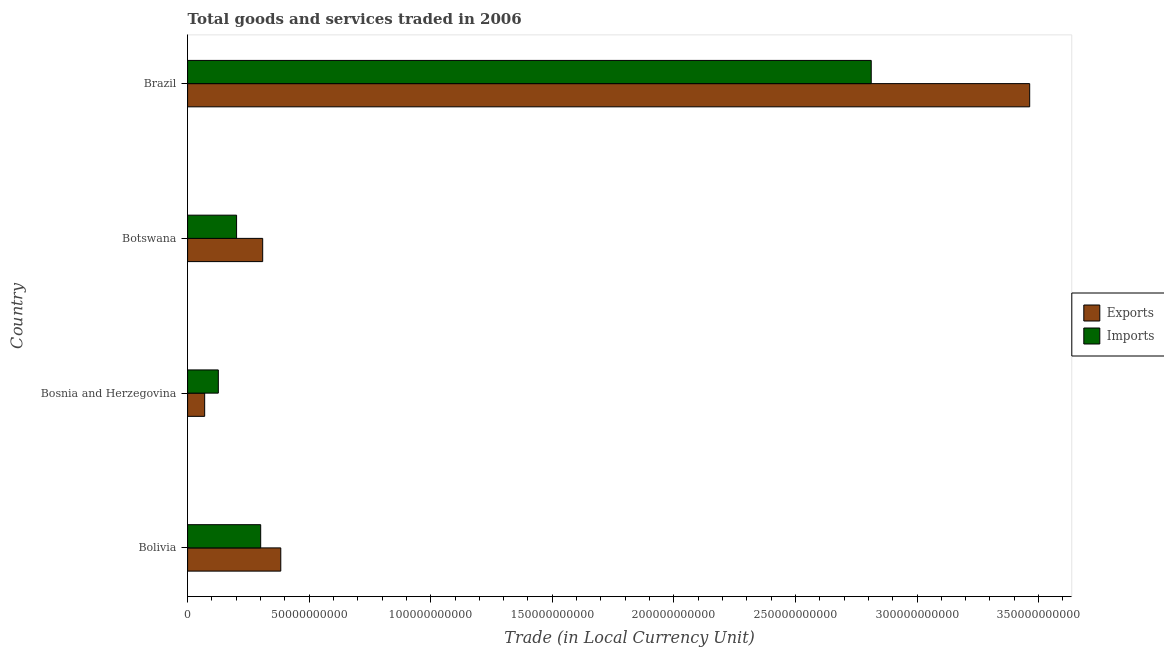How many different coloured bars are there?
Your answer should be very brief. 2. Are the number of bars per tick equal to the number of legend labels?
Your answer should be compact. Yes. How many bars are there on the 2nd tick from the top?
Ensure brevity in your answer.  2. What is the export of goods and services in Brazil?
Make the answer very short. 3.46e+11. Across all countries, what is the maximum imports of goods and services?
Make the answer very short. 2.81e+11. Across all countries, what is the minimum imports of goods and services?
Make the answer very short. 1.26e+1. In which country was the imports of goods and services minimum?
Provide a short and direct response. Bosnia and Herzegovina. What is the total export of goods and services in the graph?
Provide a short and direct response. 4.23e+11. What is the difference between the export of goods and services in Bolivia and that in Brazil?
Your answer should be very brief. -3.08e+11. What is the difference between the imports of goods and services in Brazil and the export of goods and services in Bolivia?
Keep it short and to the point. 2.43e+11. What is the average export of goods and services per country?
Provide a succinct answer. 1.06e+11. What is the difference between the export of goods and services and imports of goods and services in Brazil?
Your response must be concise. 6.52e+1. In how many countries, is the imports of goods and services greater than 60000000000 LCU?
Provide a short and direct response. 1. What is the ratio of the export of goods and services in Bosnia and Herzegovina to that in Botswana?
Offer a very short reply. 0.23. Is the export of goods and services in Bolivia less than that in Bosnia and Herzegovina?
Keep it short and to the point. No. What is the difference between the highest and the second highest export of goods and services?
Your answer should be very brief. 3.08e+11. What is the difference between the highest and the lowest imports of goods and services?
Keep it short and to the point. 2.69e+11. In how many countries, is the export of goods and services greater than the average export of goods and services taken over all countries?
Your answer should be compact. 1. What does the 1st bar from the top in Bosnia and Herzegovina represents?
Ensure brevity in your answer.  Imports. What does the 1st bar from the bottom in Bolivia represents?
Keep it short and to the point. Exports. How many bars are there?
Offer a very short reply. 8. Are all the bars in the graph horizontal?
Offer a very short reply. Yes. Are the values on the major ticks of X-axis written in scientific E-notation?
Give a very brief answer. No. Does the graph contain any zero values?
Offer a very short reply. No. Does the graph contain grids?
Offer a very short reply. No. Where does the legend appear in the graph?
Your response must be concise. Center right. How many legend labels are there?
Offer a very short reply. 2. How are the legend labels stacked?
Ensure brevity in your answer.  Vertical. What is the title of the graph?
Provide a succinct answer. Total goods and services traded in 2006. What is the label or title of the X-axis?
Your response must be concise. Trade (in Local Currency Unit). What is the label or title of the Y-axis?
Offer a very short reply. Country. What is the Trade (in Local Currency Unit) of Exports in Bolivia?
Provide a short and direct response. 3.83e+1. What is the Trade (in Local Currency Unit) in Imports in Bolivia?
Provide a succinct answer. 3.01e+1. What is the Trade (in Local Currency Unit) of Exports in Bosnia and Herzegovina?
Your answer should be compact. 7.02e+09. What is the Trade (in Local Currency Unit) of Imports in Bosnia and Herzegovina?
Ensure brevity in your answer.  1.26e+1. What is the Trade (in Local Currency Unit) of Exports in Botswana?
Offer a very short reply. 3.09e+1. What is the Trade (in Local Currency Unit) in Imports in Botswana?
Keep it short and to the point. 2.01e+1. What is the Trade (in Local Currency Unit) in Exports in Brazil?
Your answer should be compact. 3.46e+11. What is the Trade (in Local Currency Unit) in Imports in Brazil?
Offer a terse response. 2.81e+11. Across all countries, what is the maximum Trade (in Local Currency Unit) in Exports?
Offer a terse response. 3.46e+11. Across all countries, what is the maximum Trade (in Local Currency Unit) of Imports?
Make the answer very short. 2.81e+11. Across all countries, what is the minimum Trade (in Local Currency Unit) in Exports?
Offer a very short reply. 7.02e+09. Across all countries, what is the minimum Trade (in Local Currency Unit) in Imports?
Ensure brevity in your answer.  1.26e+1. What is the total Trade (in Local Currency Unit) in Exports in the graph?
Ensure brevity in your answer.  4.23e+11. What is the total Trade (in Local Currency Unit) of Imports in the graph?
Ensure brevity in your answer.  3.44e+11. What is the difference between the Trade (in Local Currency Unit) in Exports in Bolivia and that in Bosnia and Herzegovina?
Keep it short and to the point. 3.13e+1. What is the difference between the Trade (in Local Currency Unit) of Imports in Bolivia and that in Bosnia and Herzegovina?
Ensure brevity in your answer.  1.74e+1. What is the difference between the Trade (in Local Currency Unit) of Exports in Bolivia and that in Botswana?
Ensure brevity in your answer.  7.44e+09. What is the difference between the Trade (in Local Currency Unit) in Imports in Bolivia and that in Botswana?
Offer a terse response. 9.92e+09. What is the difference between the Trade (in Local Currency Unit) of Exports in Bolivia and that in Brazil?
Your answer should be very brief. -3.08e+11. What is the difference between the Trade (in Local Currency Unit) of Imports in Bolivia and that in Brazil?
Provide a succinct answer. -2.51e+11. What is the difference between the Trade (in Local Currency Unit) in Exports in Bosnia and Herzegovina and that in Botswana?
Keep it short and to the point. -2.39e+1. What is the difference between the Trade (in Local Currency Unit) in Imports in Bosnia and Herzegovina and that in Botswana?
Offer a terse response. -7.50e+09. What is the difference between the Trade (in Local Currency Unit) in Exports in Bosnia and Herzegovina and that in Brazil?
Your answer should be very brief. -3.39e+11. What is the difference between the Trade (in Local Currency Unit) in Imports in Bosnia and Herzegovina and that in Brazil?
Offer a terse response. -2.69e+11. What is the difference between the Trade (in Local Currency Unit) of Exports in Botswana and that in Brazil?
Keep it short and to the point. -3.15e+11. What is the difference between the Trade (in Local Currency Unit) in Imports in Botswana and that in Brazil?
Your answer should be very brief. -2.61e+11. What is the difference between the Trade (in Local Currency Unit) of Exports in Bolivia and the Trade (in Local Currency Unit) of Imports in Bosnia and Herzegovina?
Your answer should be very brief. 2.57e+1. What is the difference between the Trade (in Local Currency Unit) in Exports in Bolivia and the Trade (in Local Currency Unit) in Imports in Botswana?
Offer a very short reply. 1.82e+1. What is the difference between the Trade (in Local Currency Unit) of Exports in Bolivia and the Trade (in Local Currency Unit) of Imports in Brazil?
Ensure brevity in your answer.  -2.43e+11. What is the difference between the Trade (in Local Currency Unit) of Exports in Bosnia and Herzegovina and the Trade (in Local Currency Unit) of Imports in Botswana?
Your answer should be compact. -1.31e+1. What is the difference between the Trade (in Local Currency Unit) of Exports in Bosnia and Herzegovina and the Trade (in Local Currency Unit) of Imports in Brazil?
Your response must be concise. -2.74e+11. What is the difference between the Trade (in Local Currency Unit) in Exports in Botswana and the Trade (in Local Currency Unit) in Imports in Brazil?
Offer a terse response. -2.50e+11. What is the average Trade (in Local Currency Unit) of Exports per country?
Make the answer very short. 1.06e+11. What is the average Trade (in Local Currency Unit) in Imports per country?
Your answer should be very brief. 8.60e+1. What is the difference between the Trade (in Local Currency Unit) of Exports and Trade (in Local Currency Unit) of Imports in Bolivia?
Give a very brief answer. 8.26e+09. What is the difference between the Trade (in Local Currency Unit) of Exports and Trade (in Local Currency Unit) of Imports in Bosnia and Herzegovina?
Your answer should be compact. -5.62e+09. What is the difference between the Trade (in Local Currency Unit) of Exports and Trade (in Local Currency Unit) of Imports in Botswana?
Provide a succinct answer. 1.07e+1. What is the difference between the Trade (in Local Currency Unit) of Exports and Trade (in Local Currency Unit) of Imports in Brazil?
Keep it short and to the point. 6.52e+1. What is the ratio of the Trade (in Local Currency Unit) in Exports in Bolivia to that in Bosnia and Herzegovina?
Offer a very short reply. 5.46. What is the ratio of the Trade (in Local Currency Unit) in Imports in Bolivia to that in Bosnia and Herzegovina?
Your response must be concise. 2.38. What is the ratio of the Trade (in Local Currency Unit) in Exports in Bolivia to that in Botswana?
Provide a succinct answer. 1.24. What is the ratio of the Trade (in Local Currency Unit) in Imports in Bolivia to that in Botswana?
Offer a very short reply. 1.49. What is the ratio of the Trade (in Local Currency Unit) in Exports in Bolivia to that in Brazil?
Provide a short and direct response. 0.11. What is the ratio of the Trade (in Local Currency Unit) in Imports in Bolivia to that in Brazil?
Your answer should be very brief. 0.11. What is the ratio of the Trade (in Local Currency Unit) of Exports in Bosnia and Herzegovina to that in Botswana?
Keep it short and to the point. 0.23. What is the ratio of the Trade (in Local Currency Unit) in Imports in Bosnia and Herzegovina to that in Botswana?
Your answer should be very brief. 0.63. What is the ratio of the Trade (in Local Currency Unit) in Exports in Bosnia and Herzegovina to that in Brazil?
Your answer should be very brief. 0.02. What is the ratio of the Trade (in Local Currency Unit) in Imports in Bosnia and Herzegovina to that in Brazil?
Offer a terse response. 0.04. What is the ratio of the Trade (in Local Currency Unit) of Exports in Botswana to that in Brazil?
Offer a very short reply. 0.09. What is the ratio of the Trade (in Local Currency Unit) of Imports in Botswana to that in Brazil?
Ensure brevity in your answer.  0.07. What is the difference between the highest and the second highest Trade (in Local Currency Unit) in Exports?
Keep it short and to the point. 3.08e+11. What is the difference between the highest and the second highest Trade (in Local Currency Unit) of Imports?
Keep it short and to the point. 2.51e+11. What is the difference between the highest and the lowest Trade (in Local Currency Unit) of Exports?
Offer a terse response. 3.39e+11. What is the difference between the highest and the lowest Trade (in Local Currency Unit) in Imports?
Your answer should be very brief. 2.69e+11. 